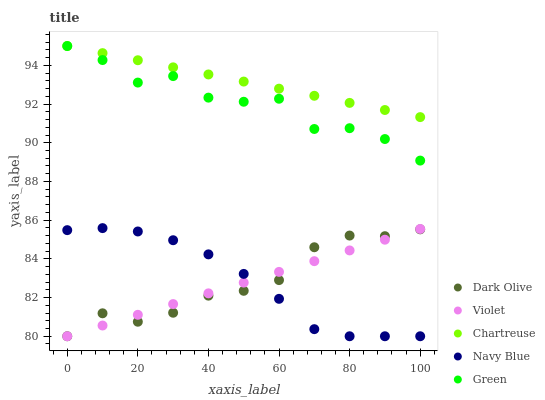Does Violet have the minimum area under the curve?
Answer yes or no. Yes. Does Chartreuse have the maximum area under the curve?
Answer yes or no. Yes. Does Dark Olive have the minimum area under the curve?
Answer yes or no. No. Does Dark Olive have the maximum area under the curve?
Answer yes or no. No. Is Violet the smoothest?
Answer yes or no. Yes. Is Green the roughest?
Answer yes or no. Yes. Is Chartreuse the smoothest?
Answer yes or no. No. Is Chartreuse the roughest?
Answer yes or no. No. Does Navy Blue have the lowest value?
Answer yes or no. Yes. Does Chartreuse have the lowest value?
Answer yes or no. No. Does Green have the highest value?
Answer yes or no. Yes. Does Dark Olive have the highest value?
Answer yes or no. No. Is Dark Olive less than Green?
Answer yes or no. Yes. Is Chartreuse greater than Violet?
Answer yes or no. Yes. Does Navy Blue intersect Dark Olive?
Answer yes or no. Yes. Is Navy Blue less than Dark Olive?
Answer yes or no. No. Is Navy Blue greater than Dark Olive?
Answer yes or no. No. Does Dark Olive intersect Green?
Answer yes or no. No. 